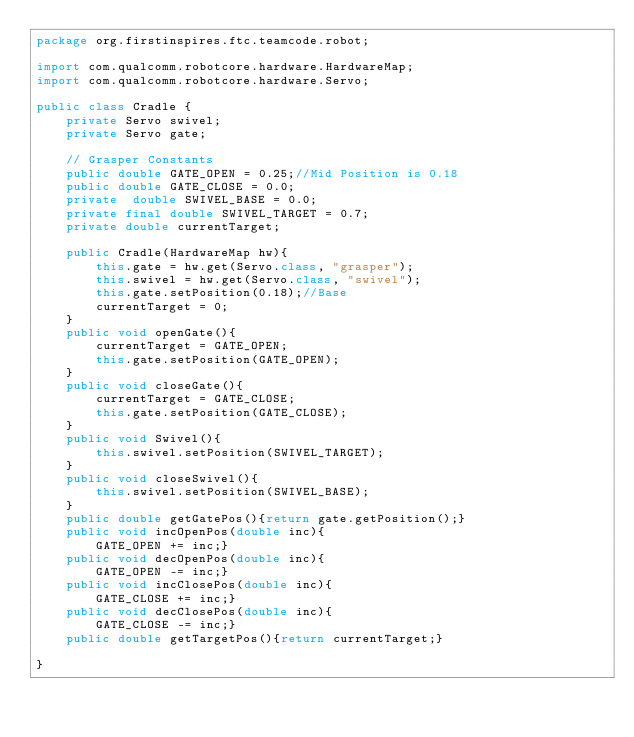Convert code to text. <code><loc_0><loc_0><loc_500><loc_500><_Java_>package org.firstinspires.ftc.teamcode.robot;

import com.qualcomm.robotcore.hardware.HardwareMap;
import com.qualcomm.robotcore.hardware.Servo;

public class Cradle {
    private Servo swivel;
    private Servo gate;

    // Grasper Constants
    public double GATE_OPEN = 0.25;//Mid Position is 0.18
    public double GATE_CLOSE = 0.0;
    private  double SWIVEL_BASE = 0.0;
    private final double SWIVEL_TARGET = 0.7;
    private double currentTarget;

    public Cradle(HardwareMap hw){
        this.gate = hw.get(Servo.class, "grasper");
        this.swivel = hw.get(Servo.class, "swivel");
        this.gate.setPosition(0.18);//Base
        currentTarget = 0;
    }
    public void openGate(){
        currentTarget = GATE_OPEN;
        this.gate.setPosition(GATE_OPEN);
    }
    public void closeGate(){
        currentTarget = GATE_CLOSE;
        this.gate.setPosition(GATE_CLOSE);
    }
    public void Swivel(){
        this.swivel.setPosition(SWIVEL_TARGET);
    }
    public void closeSwivel(){
        this.swivel.setPosition(SWIVEL_BASE);
    }
    public double getGatePos(){return gate.getPosition();}
    public void incOpenPos(double inc){
        GATE_OPEN += inc;}
    public void decOpenPos(double inc){
        GATE_OPEN -= inc;}
    public void incClosePos(double inc){
        GATE_CLOSE += inc;}
    public void decClosePos(double inc){
        GATE_CLOSE -= inc;}
    public double getTargetPos(){return currentTarget;}

}
</code> 